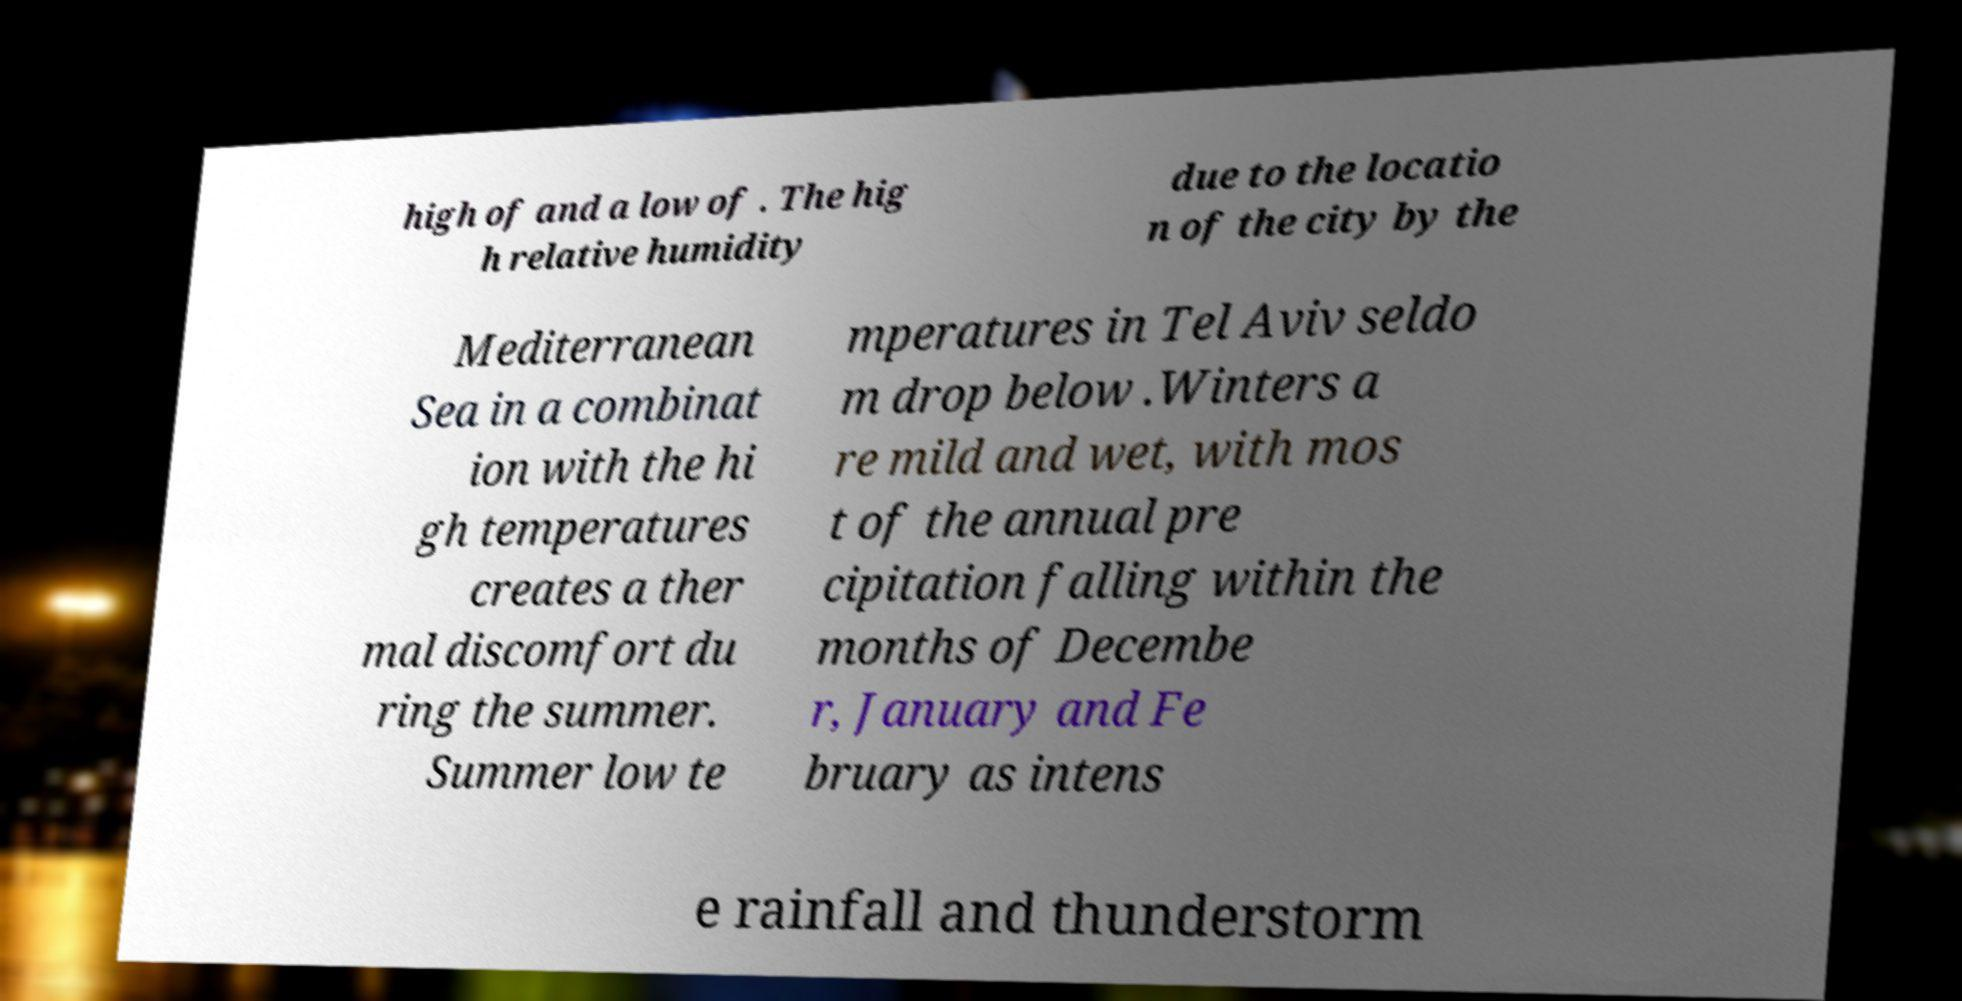Please read and relay the text visible in this image. What does it say? high of and a low of . The hig h relative humidity due to the locatio n of the city by the Mediterranean Sea in a combinat ion with the hi gh temperatures creates a ther mal discomfort du ring the summer. Summer low te mperatures in Tel Aviv seldo m drop below .Winters a re mild and wet, with mos t of the annual pre cipitation falling within the months of Decembe r, January and Fe bruary as intens e rainfall and thunderstorm 